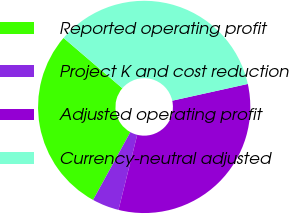Convert chart to OTSL. <chart><loc_0><loc_0><loc_500><loc_500><pie_chart><fcel>Reported operating profit<fcel>Project K and cost reduction<fcel>Adjusted operating profit<fcel>Currency-neutral adjusted<nl><fcel>28.27%<fcel>4.1%<fcel>32.37%<fcel>35.26%<nl></chart> 